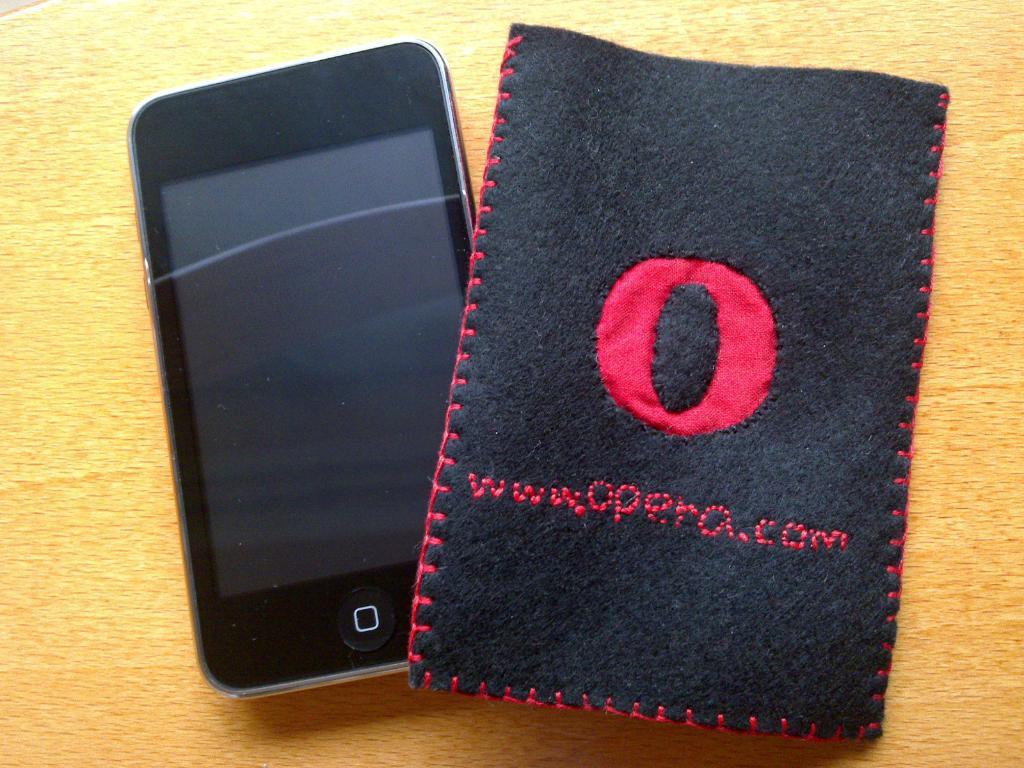What is the website on this cloth?
Provide a succinct answer. Www.opera.com. What is the letter in the middle of the case?
Your answer should be compact. O. 